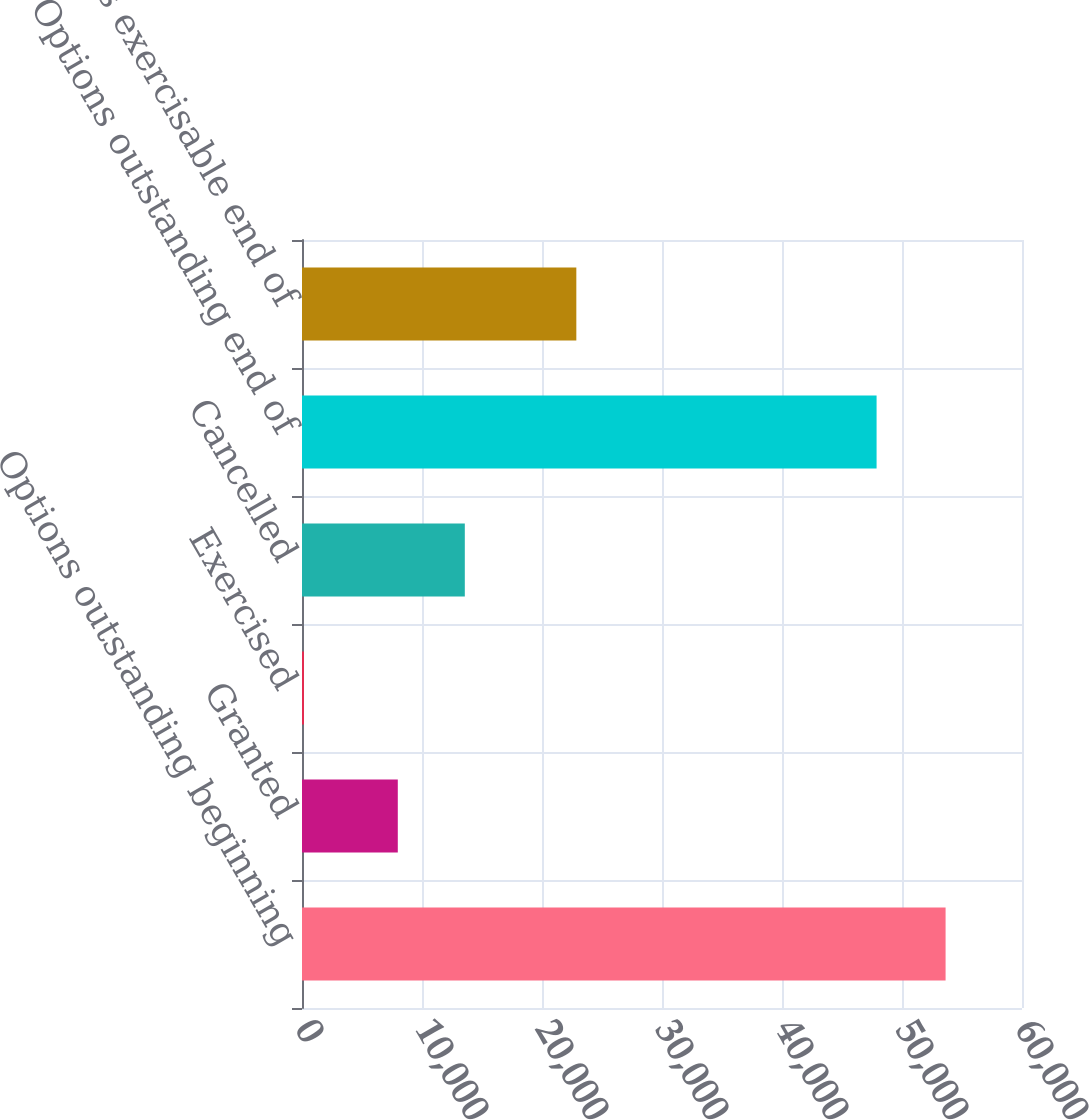Convert chart. <chart><loc_0><loc_0><loc_500><loc_500><bar_chart><fcel>Options outstanding beginning<fcel>Granted<fcel>Exercised<fcel>Cancelled<fcel>Options outstanding end of<fcel>Options exercisable end of<nl><fcel>53632<fcel>7983<fcel>165<fcel>13568<fcel>47882<fcel>22861<nl></chart> 